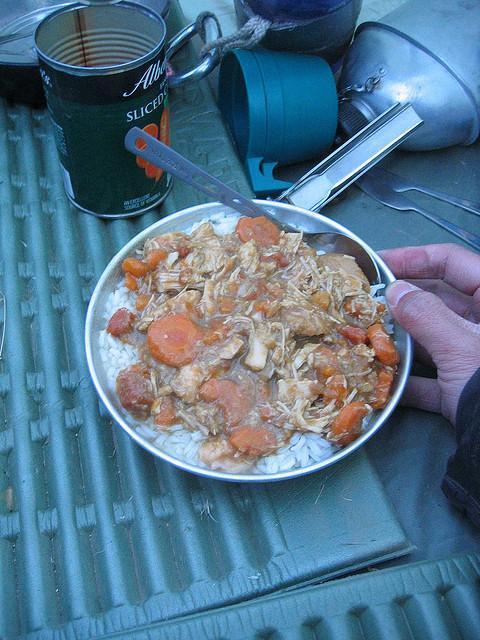How many cups are in the photo?
Give a very brief answer. 2. 